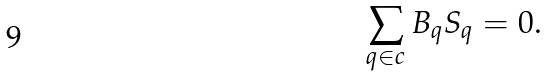Convert formula to latex. <formula><loc_0><loc_0><loc_500><loc_500>\sum _ { q \in c } B _ { q } S _ { q } = 0 .</formula> 